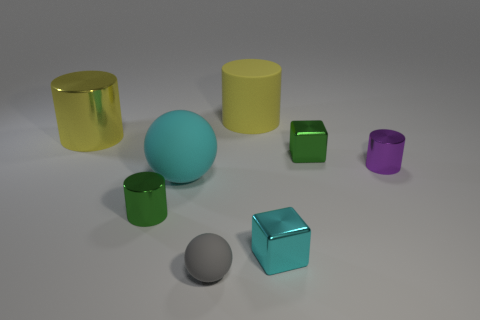Does the gray matte thing that is in front of the cyan ball have the same size as the matte cylinder left of the purple cylinder? no 